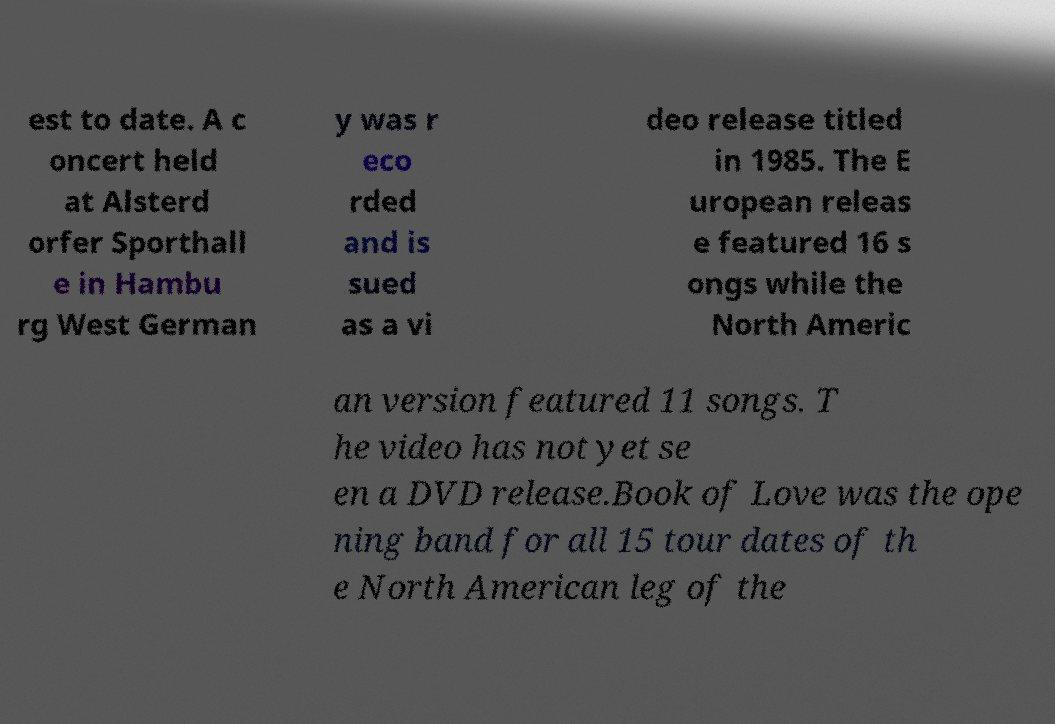What messages or text are displayed in this image? I need them in a readable, typed format. est to date. A c oncert held at Alsterd orfer Sporthall e in Hambu rg West German y was r eco rded and is sued as a vi deo release titled in 1985. The E uropean releas e featured 16 s ongs while the North Americ an version featured 11 songs. T he video has not yet se en a DVD release.Book of Love was the ope ning band for all 15 tour dates of th e North American leg of the 